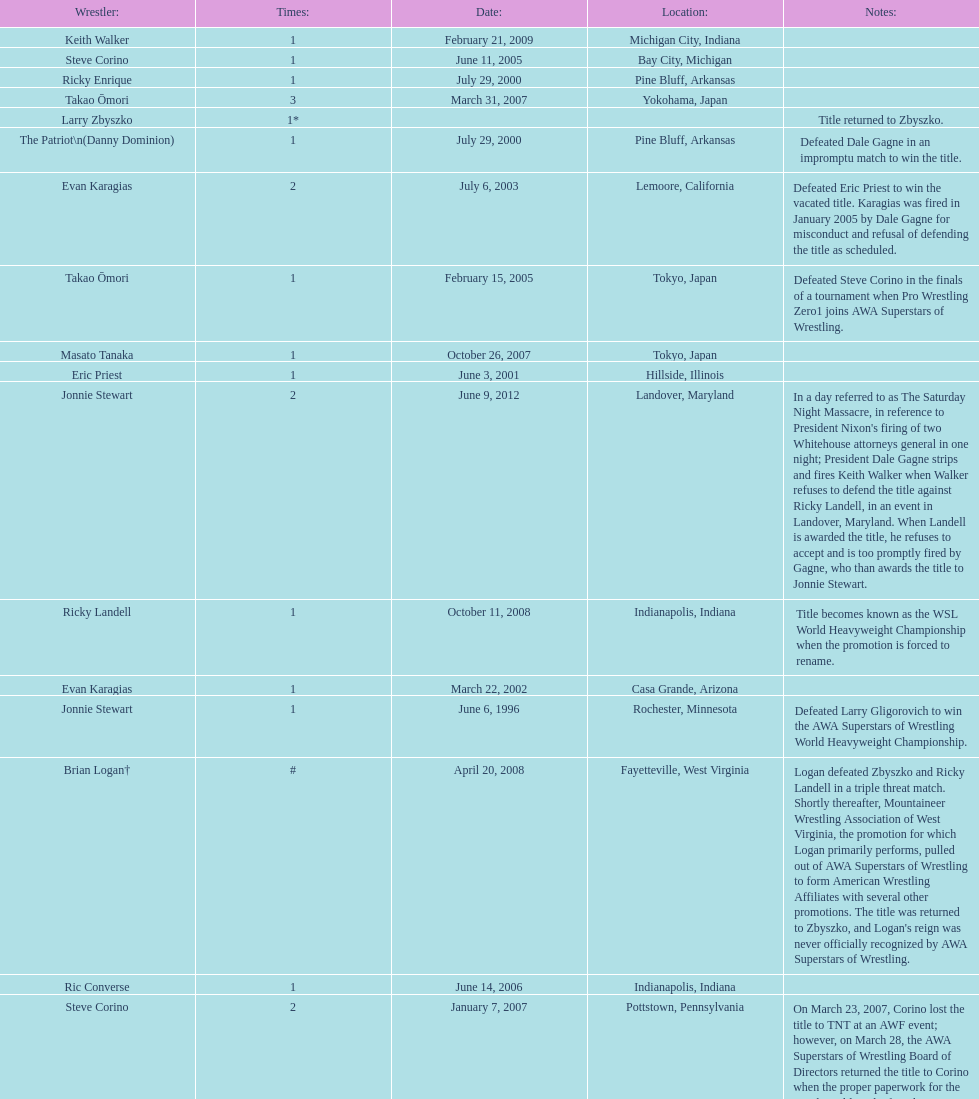Who is the only wsl title holder from texas? Horshu. 